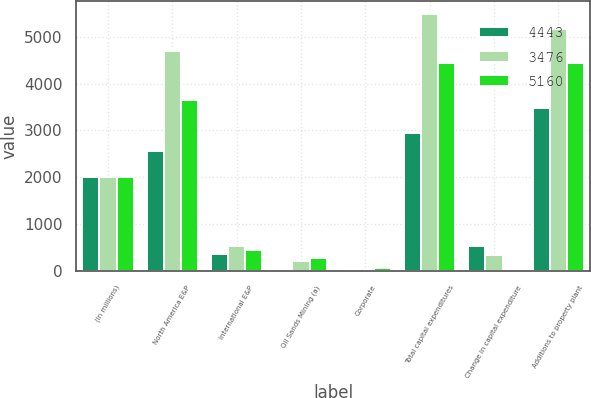Convert chart. <chart><loc_0><loc_0><loc_500><loc_500><stacked_bar_chart><ecel><fcel>(In millions)<fcel>North America E&P<fcel>International E&P<fcel>Oil Sands Mining (a)<fcel>Corporate<fcel>Total capital expenditures<fcel>Change in capital expenditure<fcel>Additions to property plant<nl><fcel>4443<fcel>2015<fcel>2553<fcel>368<fcel>10<fcel>25<fcel>2936<fcel>540<fcel>3476<nl><fcel>3476<fcel>2014<fcel>4698<fcel>534<fcel>212<fcel>51<fcel>5495<fcel>335<fcel>5160<nl><fcel>5160<fcel>2013<fcel>3649<fcel>456<fcel>286<fcel>58<fcel>4449<fcel>6<fcel>4443<nl></chart> 